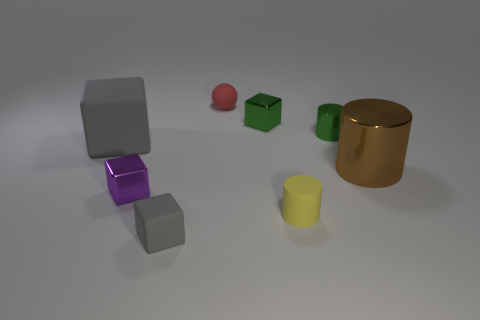Is there anything else that has the same color as the small sphere?
Your answer should be very brief. No. Are there any large green rubber blocks?
Your response must be concise. No. There is a matte block that is behind the yellow matte cylinder; is its size the same as the gray matte cube that is in front of the tiny purple thing?
Your answer should be compact. No. What material is the object that is on the left side of the matte cylinder and on the right side of the red rubber ball?
Provide a succinct answer. Metal. How many purple cubes are behind the tiny gray block?
Provide a short and direct response. 1. Is there any other thing that is the same size as the rubber cylinder?
Give a very brief answer. Yes. There is another block that is the same material as the tiny green block; what is its color?
Your answer should be very brief. Purple. Is the shape of the small gray object the same as the purple object?
Provide a succinct answer. Yes. What number of small metallic cubes are both to the right of the small gray rubber block and in front of the large rubber cube?
Your answer should be very brief. 0. What number of shiny things are either large cubes or purple blocks?
Offer a terse response. 1. 